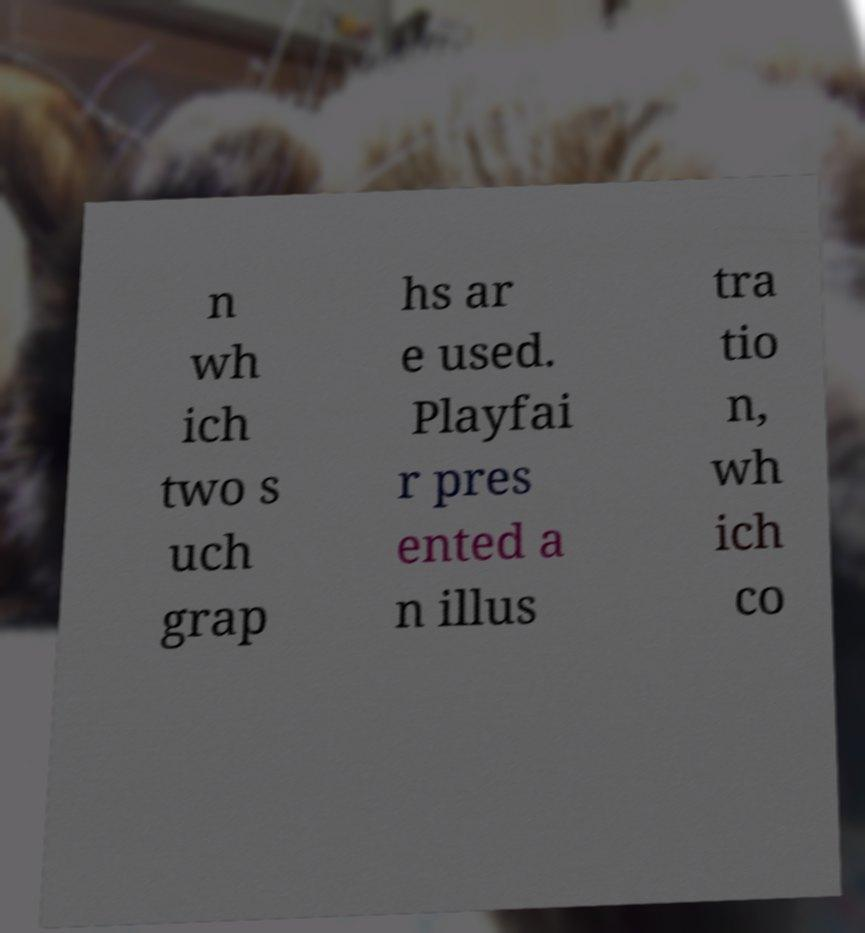Please read and relay the text visible in this image. What does it say? n wh ich two s uch grap hs ar e used. Playfai r pres ented a n illus tra tio n, wh ich co 